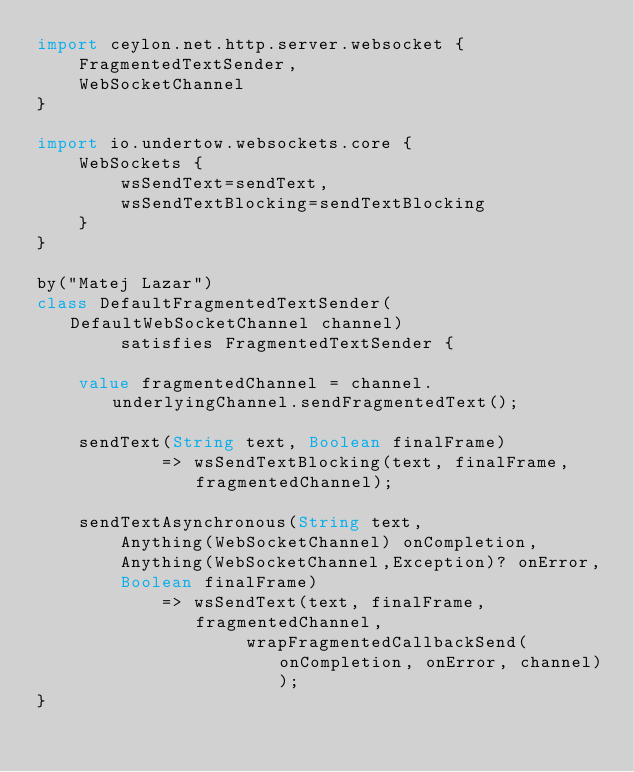Convert code to text. <code><loc_0><loc_0><loc_500><loc_500><_Ceylon_>import ceylon.net.http.server.websocket {
    FragmentedTextSender,
    WebSocketChannel
}

import io.undertow.websockets.core {
    WebSockets {
        wsSendText=sendText,
        wsSendTextBlocking=sendTextBlocking
    }
}

by("Matej Lazar")
class DefaultFragmentedTextSender(DefaultWebSocketChannel channel) 
        satisfies FragmentedTextSender {

    value fragmentedChannel = channel.underlyingChannel.sendFragmentedText();

    sendText(String text, Boolean finalFrame) 
            => wsSendTextBlocking(text, finalFrame, fragmentedChannel);
    
    sendTextAsynchronous(String text,
        Anything(WebSocketChannel) onCompletion,
        Anything(WebSocketChannel,Exception)? onError,
        Boolean finalFrame) 
            => wsSendText(text, finalFrame, fragmentedChannel, 
                    wrapFragmentedCallbackSend(onCompletion, onError, channel));
}
</code> 